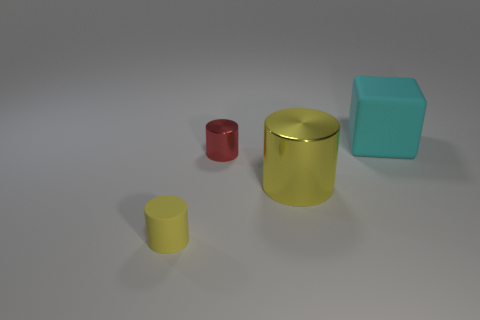Which object in the image appears to be the smallest? The object that appears to be the smallest is the red cylinder; it's a vibrant shade of red, providing a stark contrast to the larger objects. 